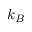Convert formula to latex. <formula><loc_0><loc_0><loc_500><loc_500>k _ { B }</formula> 